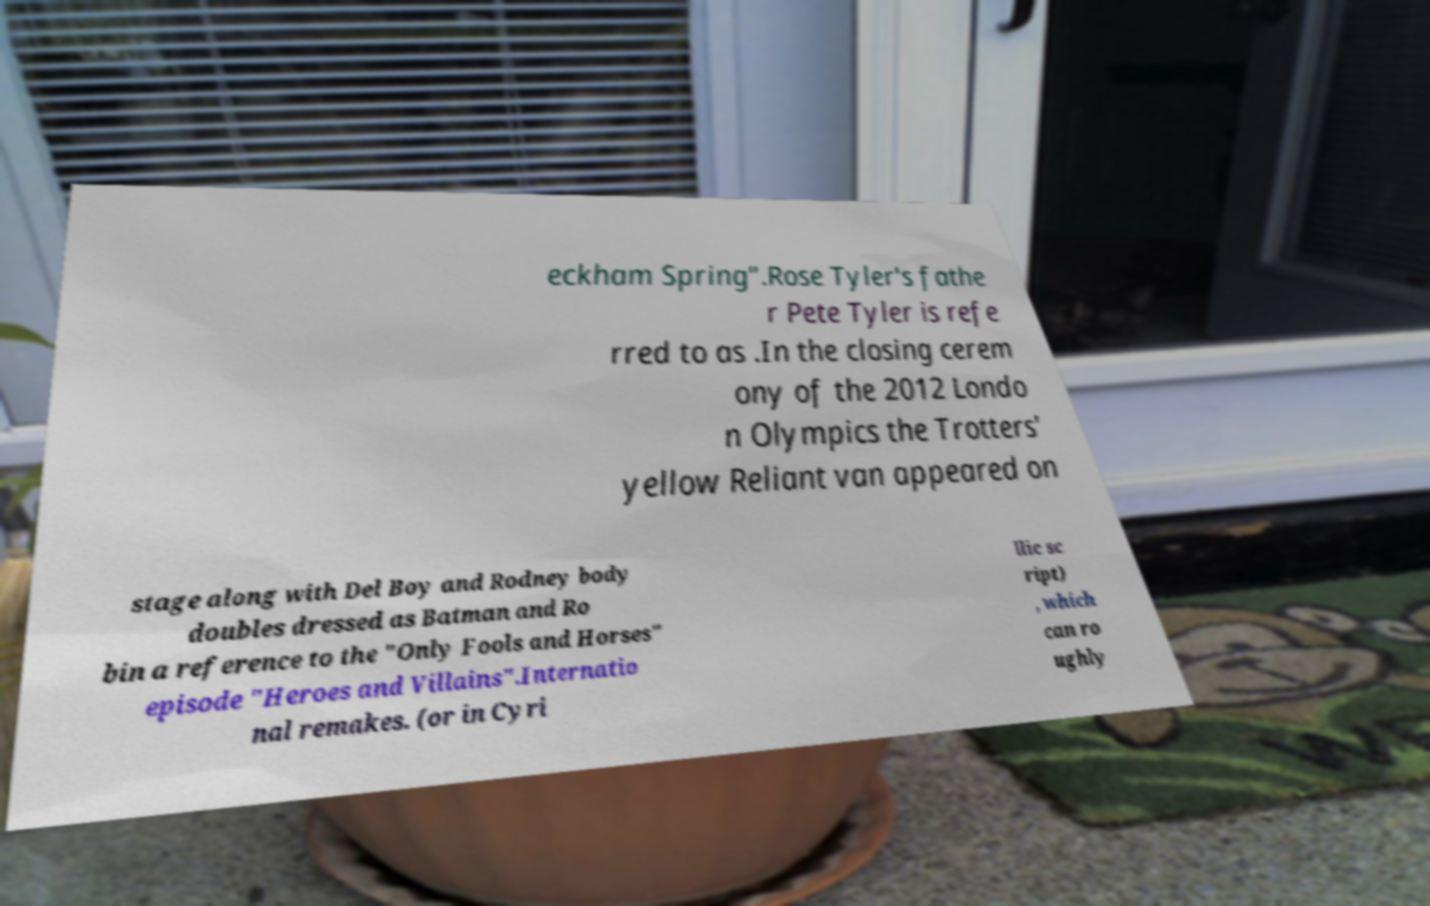I need the written content from this picture converted into text. Can you do that? eckham Spring".Rose Tyler's fathe r Pete Tyler is refe rred to as .In the closing cerem ony of the 2012 Londo n Olympics the Trotters' yellow Reliant van appeared on stage along with Del Boy and Rodney body doubles dressed as Batman and Ro bin a reference to the "Only Fools and Horses" episode "Heroes and Villains".Internatio nal remakes. (or in Cyri llic sc ript) , which can ro ughly 